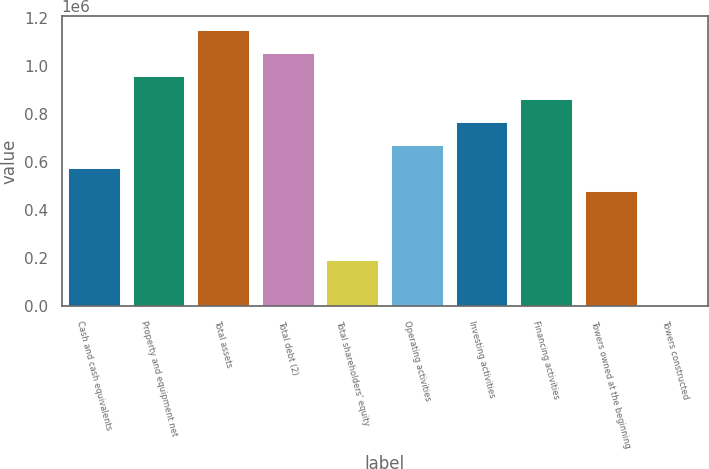<chart> <loc_0><loc_0><loc_500><loc_500><bar_chart><fcel>Cash and cash equivalents<fcel>Property and equipment net<fcel>Total assets<fcel>Total debt (2)<fcel>Total shareholders' equity<fcel>Operating activities<fcel>Investing activities<fcel>Financing activities<fcel>Towers owned at the beginning<fcel>Towers constructed<nl><fcel>574956<fcel>958252<fcel>1.1499e+06<fcel>1.05408e+06<fcel>191661<fcel>670780<fcel>766604<fcel>862428<fcel>479132<fcel>13<nl></chart> 